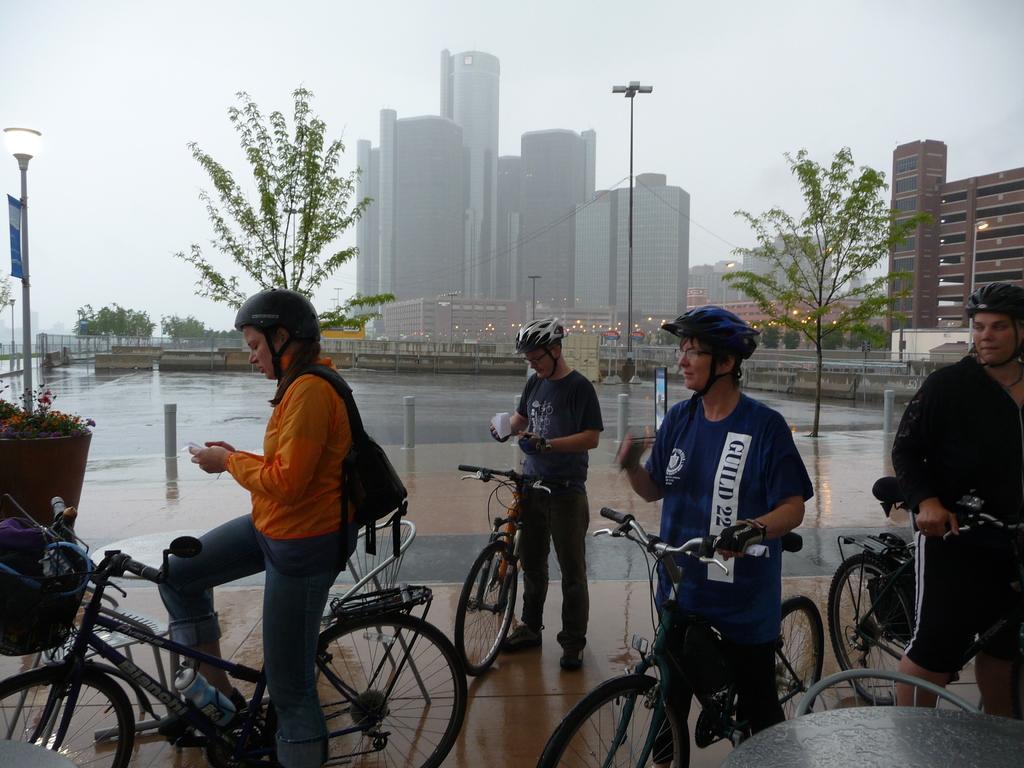Please provide a concise description of this image. In the image there are few people on cycle,it seems to be on a road,in the background there are many buildings and there are some trees towards right side and left side,the climate seems to be foggy and misty. 